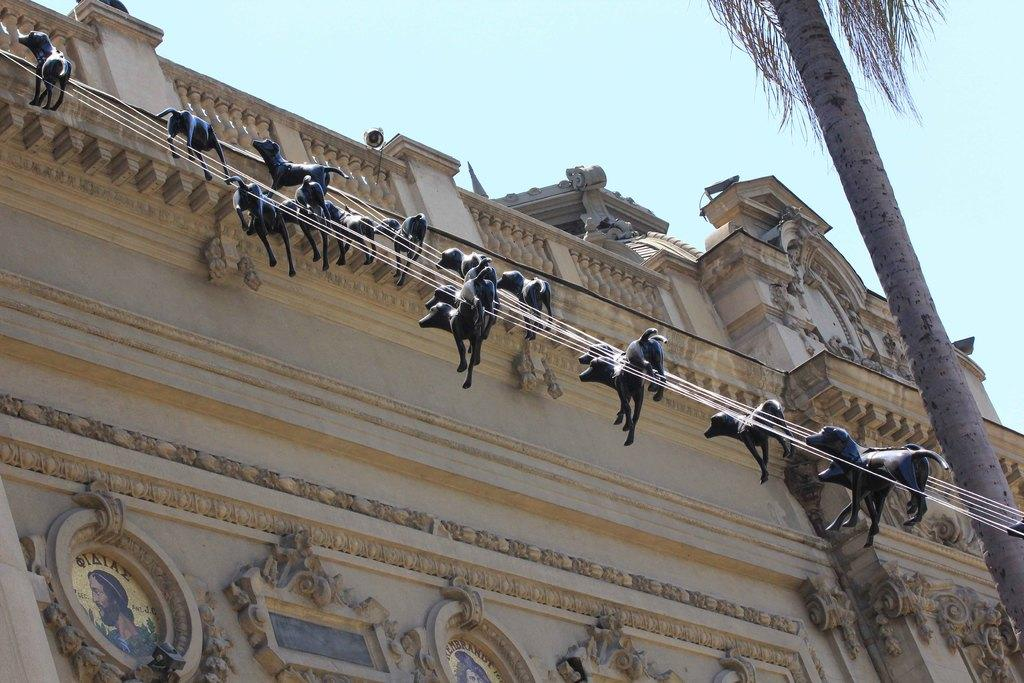What type of structure can be seen in the image? There is a building in the image. What other natural element is present in the image? There is a tree in the image. What is the color of the sky in the image? The sky is visible in the image and has a blue color. What additional objects can be seen in the image? There are animal statues in the image. How are the animal statues positioned in the image? The animal statues are attached to a rope. What type of apparel is the son wearing in the image? There is no son present in the image; it features a building, a tree, a blue sky, and animal statues attached to a rope. 